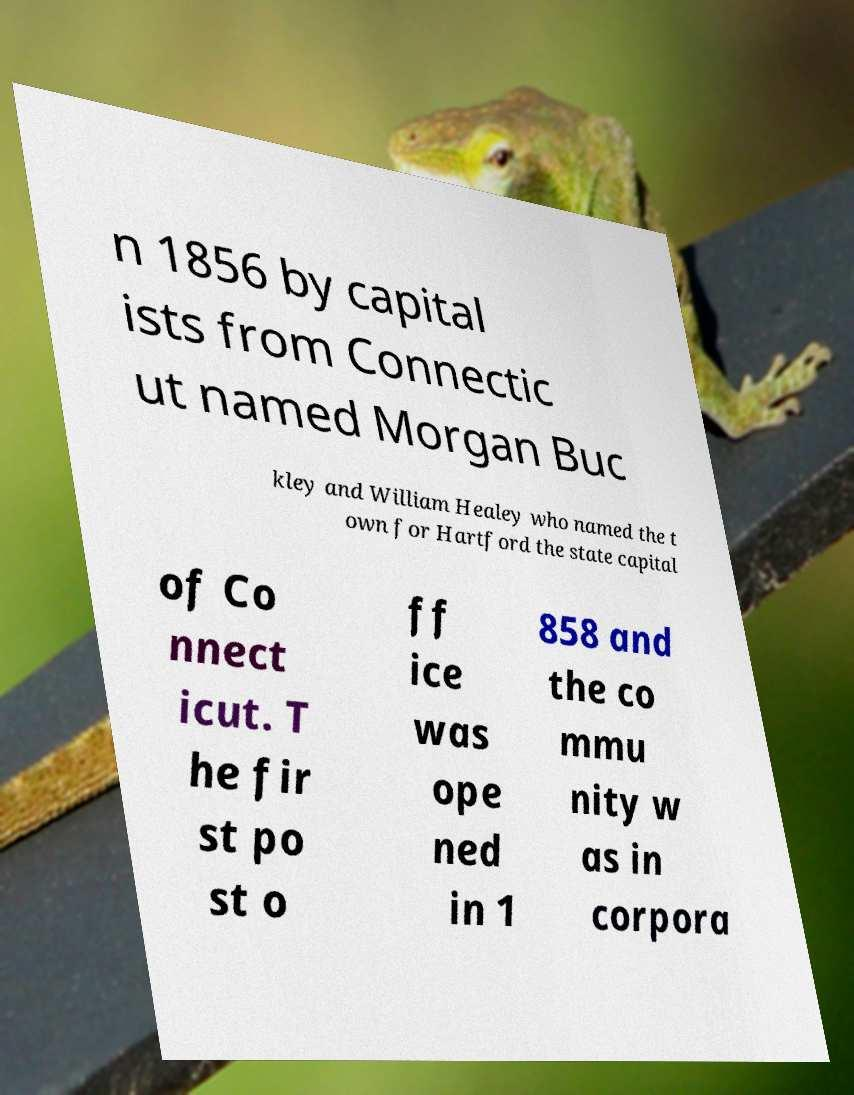Can you read and provide the text displayed in the image?This photo seems to have some interesting text. Can you extract and type it out for me? n 1856 by capital ists from Connectic ut named Morgan Buc kley and William Healey who named the t own for Hartford the state capital of Co nnect icut. T he fir st po st o ff ice was ope ned in 1 858 and the co mmu nity w as in corpora 